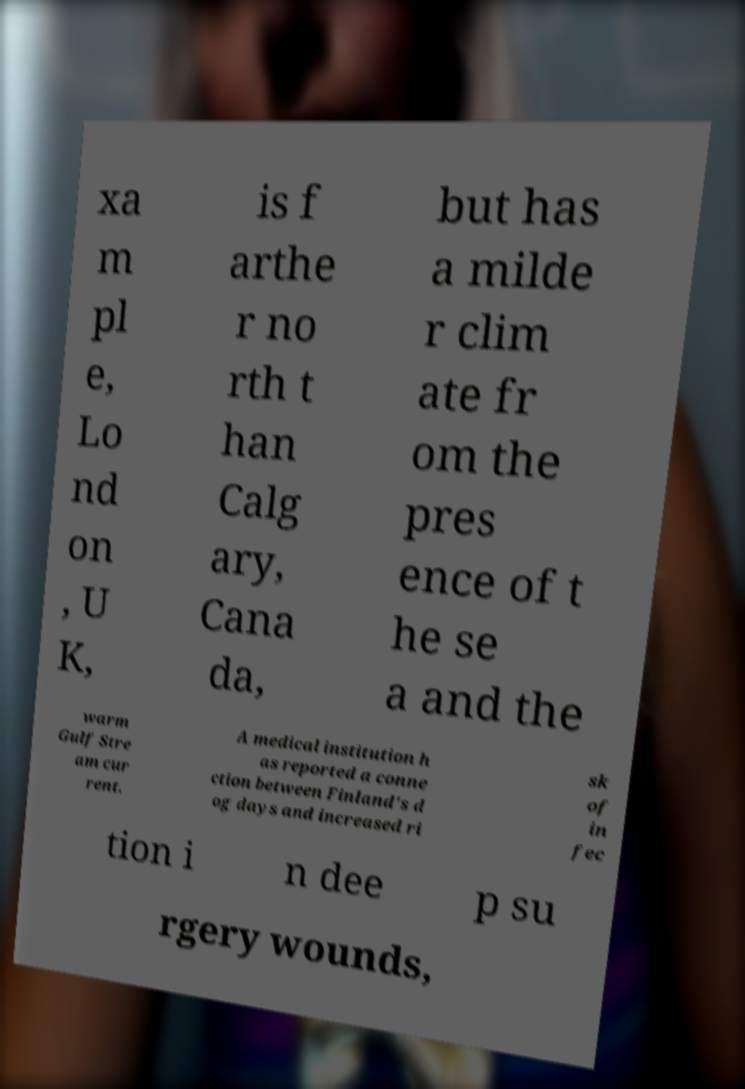I need the written content from this picture converted into text. Can you do that? xa m pl e, Lo nd on , U K, is f arthe r no rth t han Calg ary, Cana da, but has a milde r clim ate fr om the pres ence of t he se a and the warm Gulf Stre am cur rent. A medical institution h as reported a conne ction between Finland's d og days and increased ri sk of in fec tion i n dee p su rgery wounds, 